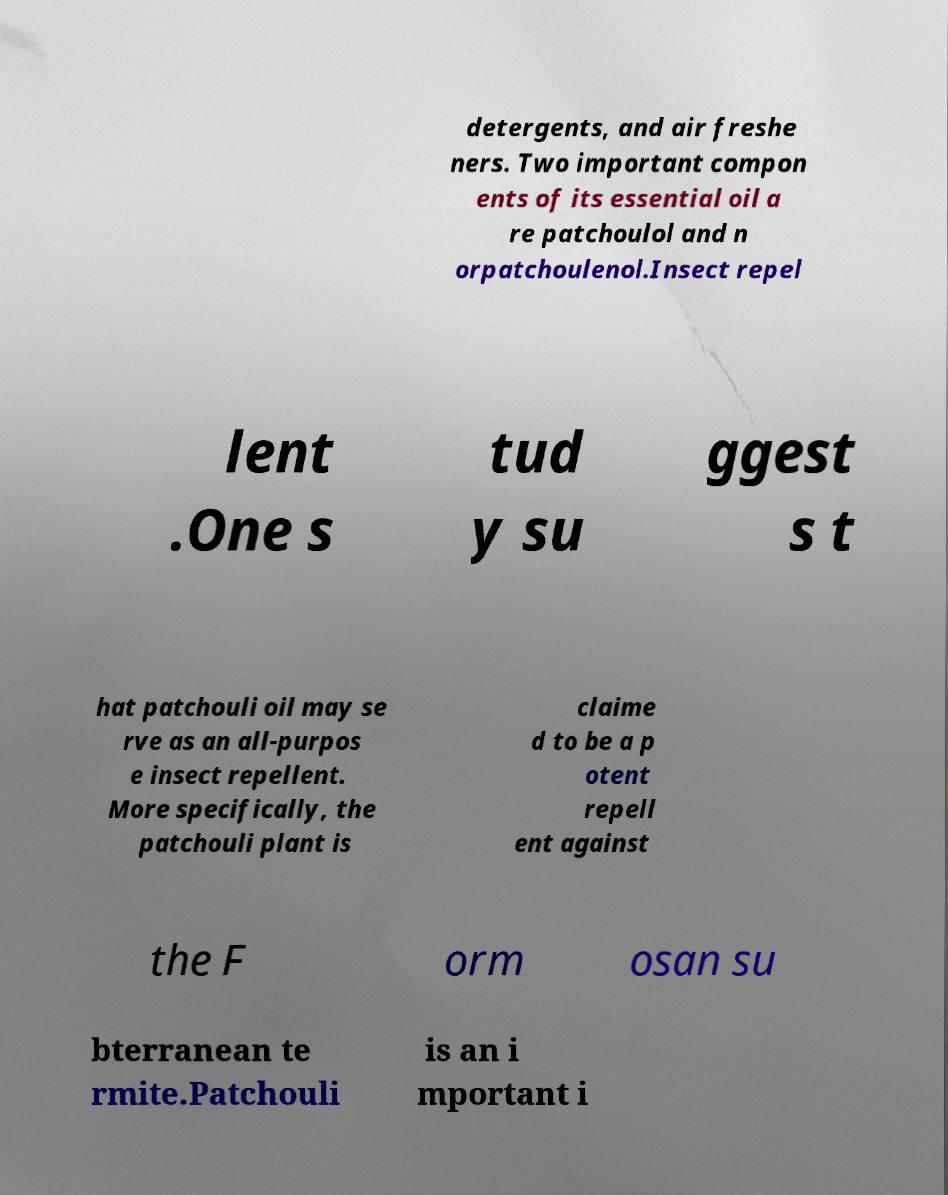I need the written content from this picture converted into text. Can you do that? detergents, and air freshe ners. Two important compon ents of its essential oil a re patchoulol and n orpatchoulenol.Insect repel lent .One s tud y su ggest s t hat patchouli oil may se rve as an all-purpos e insect repellent. More specifically, the patchouli plant is claime d to be a p otent repell ent against the F orm osan su bterranean te rmite.Patchouli is an i mportant i 